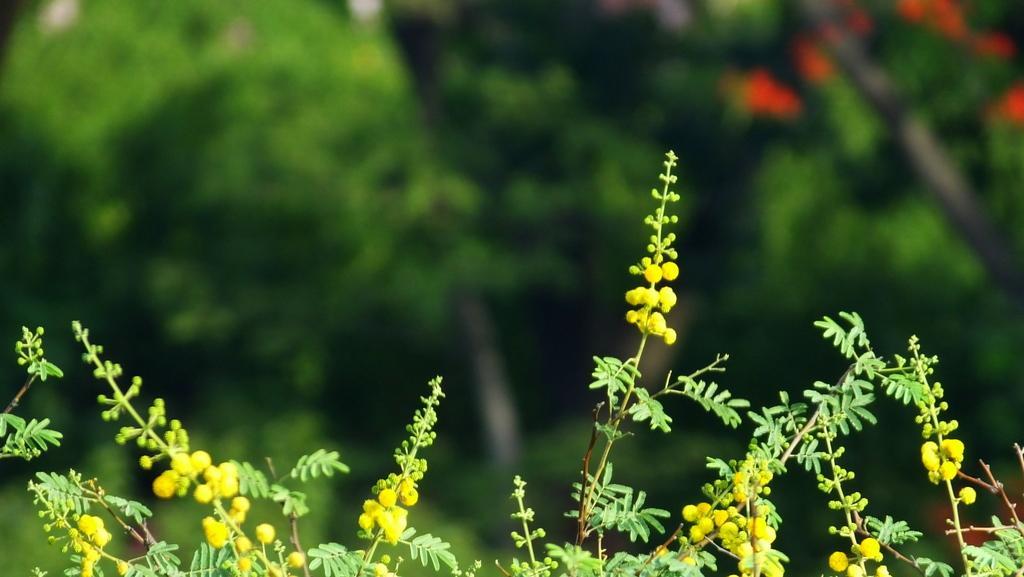Can you describe this image briefly? In this image I can see plants. The background of the image is blurred. 